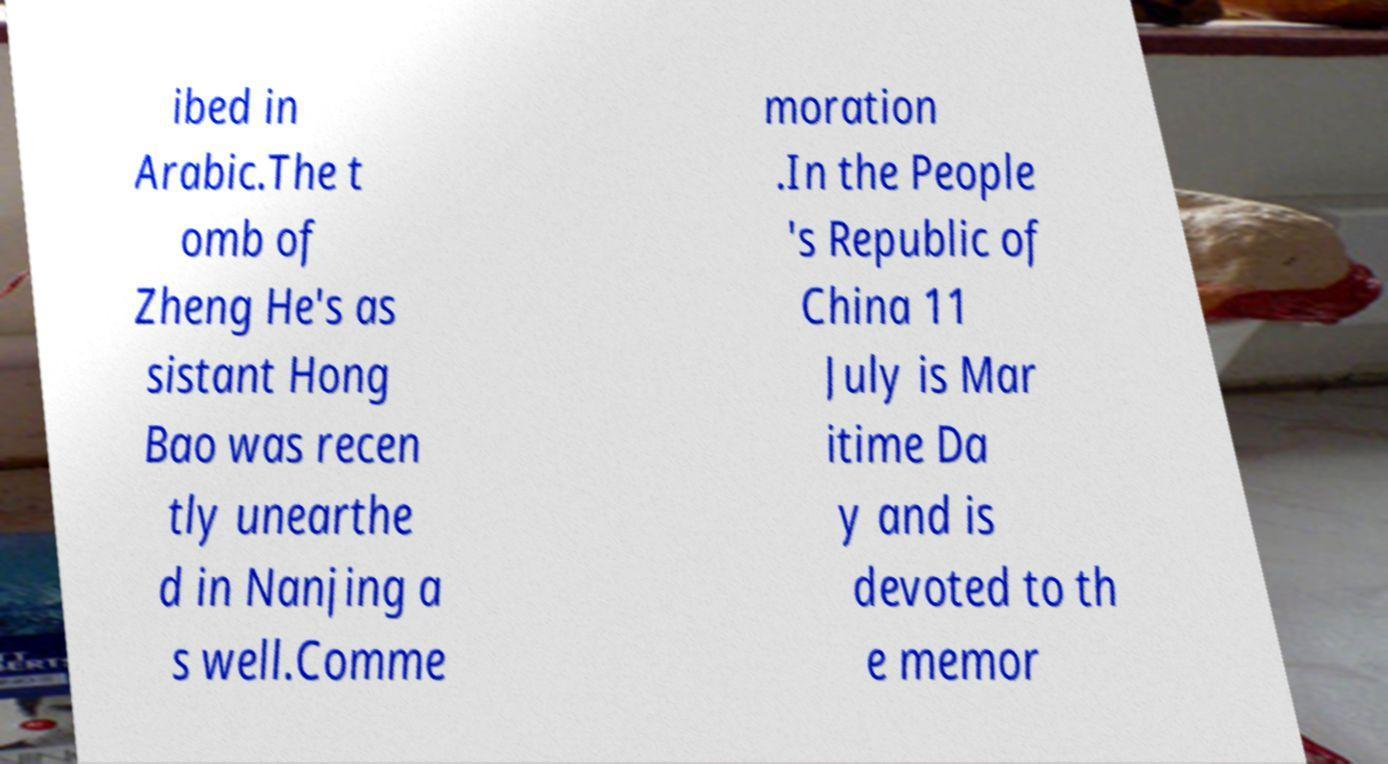Please identify and transcribe the text found in this image. ibed in Arabic.The t omb of Zheng He's as sistant Hong Bao was recen tly unearthe d in Nanjing a s well.Comme moration .In the People 's Republic of China 11 July is Mar itime Da y and is devoted to th e memor 